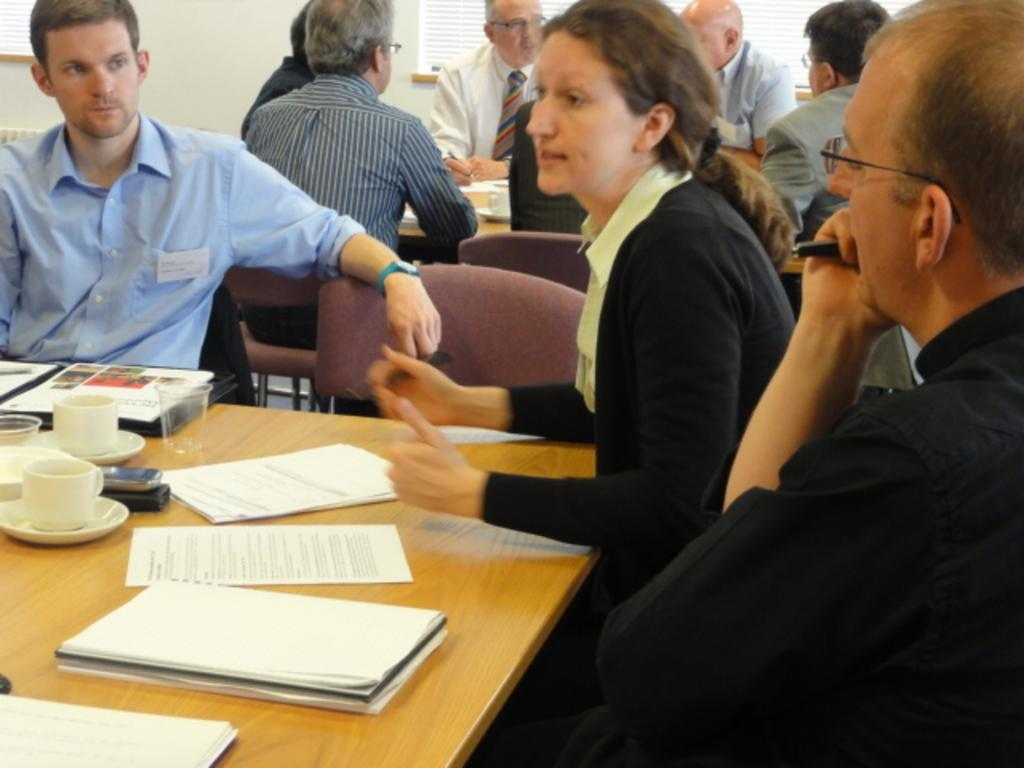What is the man's position in the image? The man is sitting on the right side of the image. What is the woman's position in the image? The woman is sitting in the middle of the image. What is the woman doing in the image? The woman is talking. What items can be seen on the table in the image? There are papers, books, tea cups, and glasses on the table. What type of haircut does the man have in the image? There is no information about the man's haircut in the image. What badge is the woman wearing in the image? There is no badge visible on the woman in the image. 